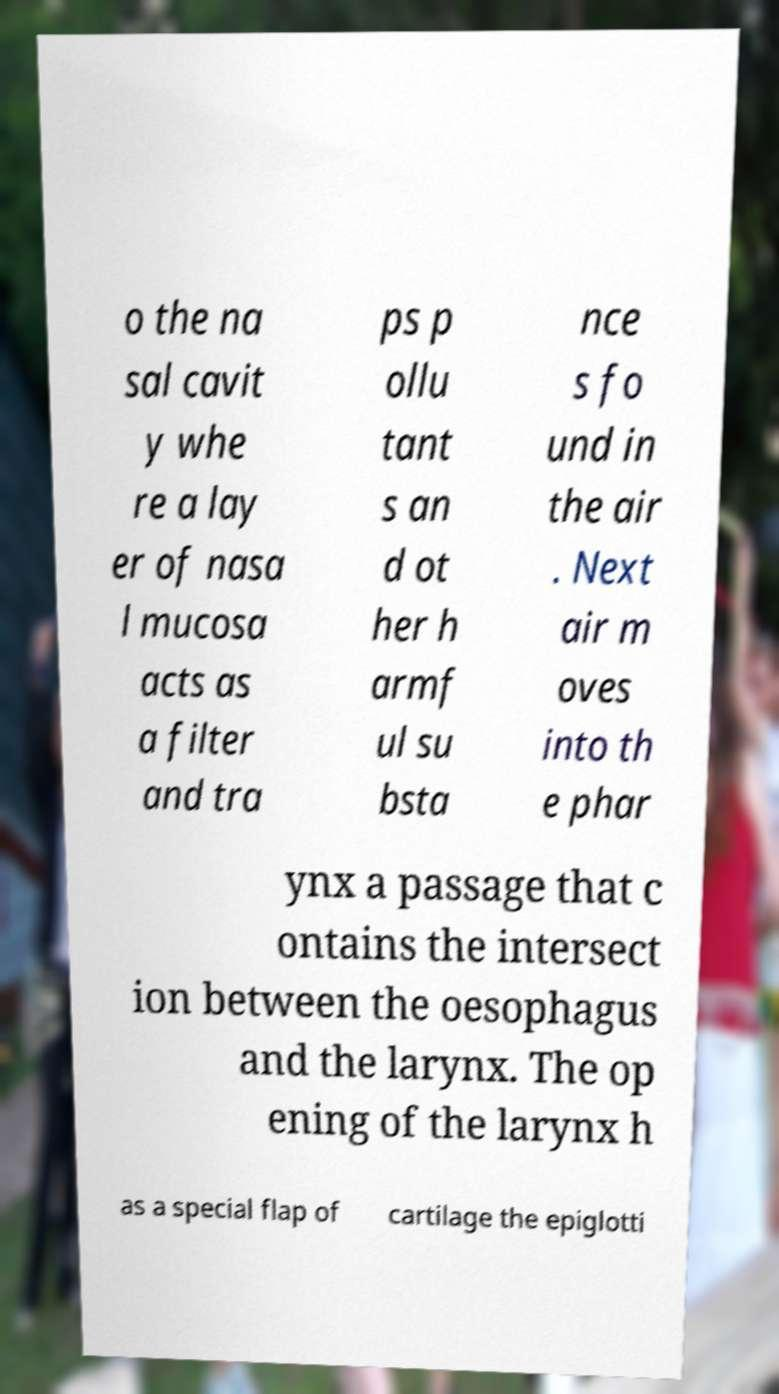Can you read and provide the text displayed in the image?This photo seems to have some interesting text. Can you extract and type it out for me? o the na sal cavit y whe re a lay er of nasa l mucosa acts as a filter and tra ps p ollu tant s an d ot her h armf ul su bsta nce s fo und in the air . Next air m oves into th e phar ynx a passage that c ontains the intersect ion between the oesophagus and the larynx. The op ening of the larynx h as a special flap of cartilage the epiglotti 